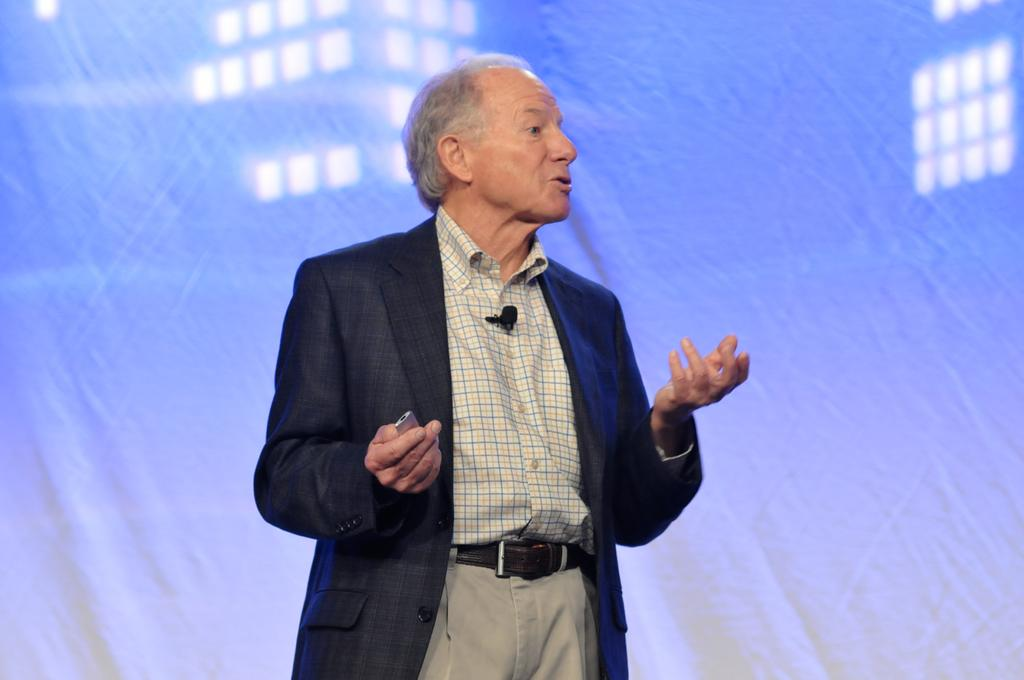Who is present in the image? There is a man in the picture. What is the man doing in the image? The man is standing and talking. What is the man wearing in the image? The man is wearing a black color blazer. What attempt is the man making to improve the acoustics in the image? There is no indication in the image that the man is attempting to improve the acoustics. 